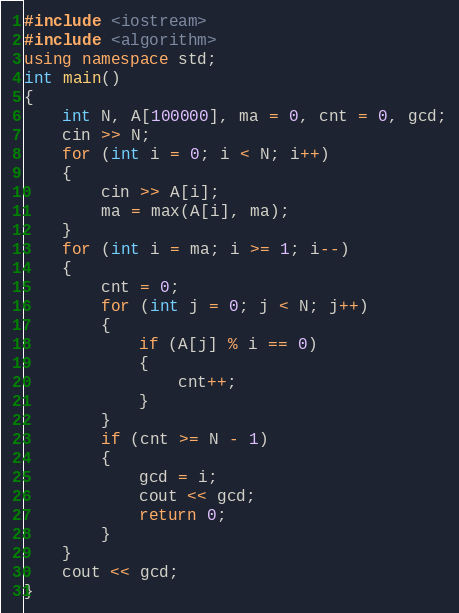<code> <loc_0><loc_0><loc_500><loc_500><_C++_>#include <iostream>
#include <algorithm>
using namespace std;
int main()
{
    int N, A[100000], ma = 0, cnt = 0, gcd;
    cin >> N;
    for (int i = 0; i < N; i++)
    {
        cin >> A[i];
        ma = max(A[i], ma);
    }
    for (int i = ma; i >= 1; i--)
    {
        cnt = 0;
        for (int j = 0; j < N; j++)
        {
            if (A[j] % i == 0)
            {
                cnt++;
            }
        }
        if (cnt >= N - 1)
        {
            gcd = i;
            cout << gcd;
            return 0;
        }
    }
    cout << gcd;
}</code> 